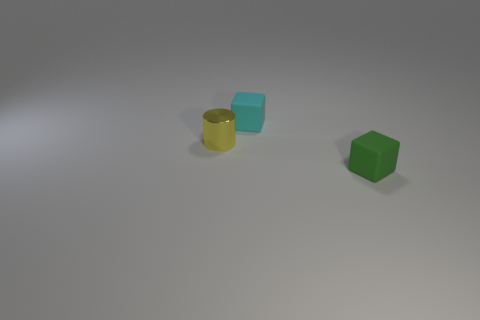Is there a tiny yellow metal cylinder in front of the cube that is in front of the cyan rubber thing that is right of the cylinder?
Ensure brevity in your answer.  No. What number of objects are either tiny rubber cubes in front of the tiny metal cylinder or small yellow things?
Offer a very short reply. 2. Are there any blue matte cylinders that have the same size as the metal thing?
Your response must be concise. No. Are there any tiny objects on the left side of the matte object that is behind the tiny metallic cylinder?
Ensure brevity in your answer.  Yes. What number of cubes are either tiny blue objects or matte objects?
Keep it short and to the point. 2. Is there a blue thing of the same shape as the tiny yellow thing?
Your answer should be compact. No. What is the shape of the small cyan matte object?
Provide a short and direct response. Cube. How many things are either green things or tiny yellow metal cylinders?
Ensure brevity in your answer.  2. There is a matte object to the right of the small cyan object; is it the same size as the rubber thing behind the small shiny cylinder?
Give a very brief answer. Yes. What number of other things are made of the same material as the green cube?
Offer a terse response. 1. 